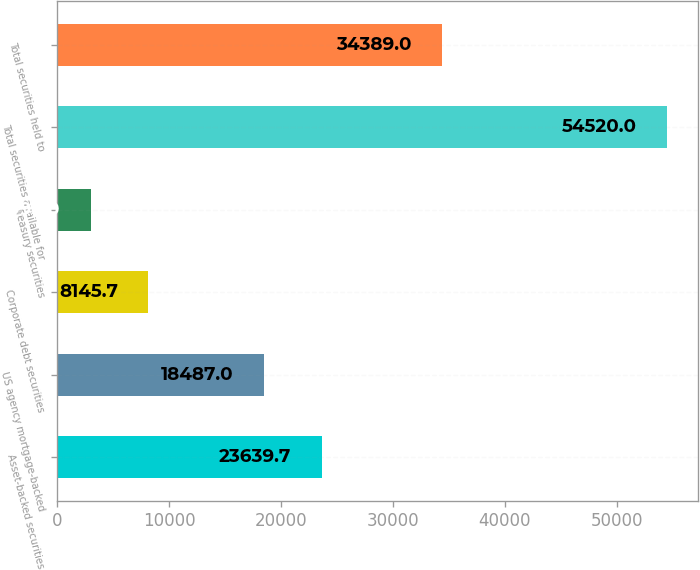Convert chart. <chart><loc_0><loc_0><loc_500><loc_500><bar_chart><fcel>Asset-backed securities<fcel>US agency mortgage-backed<fcel>Corporate debt securities<fcel>Treasury securities<fcel>Total securities available for<fcel>Total securities held to<nl><fcel>23639.7<fcel>18487<fcel>8145.7<fcel>2993<fcel>54520<fcel>34389<nl></chart> 